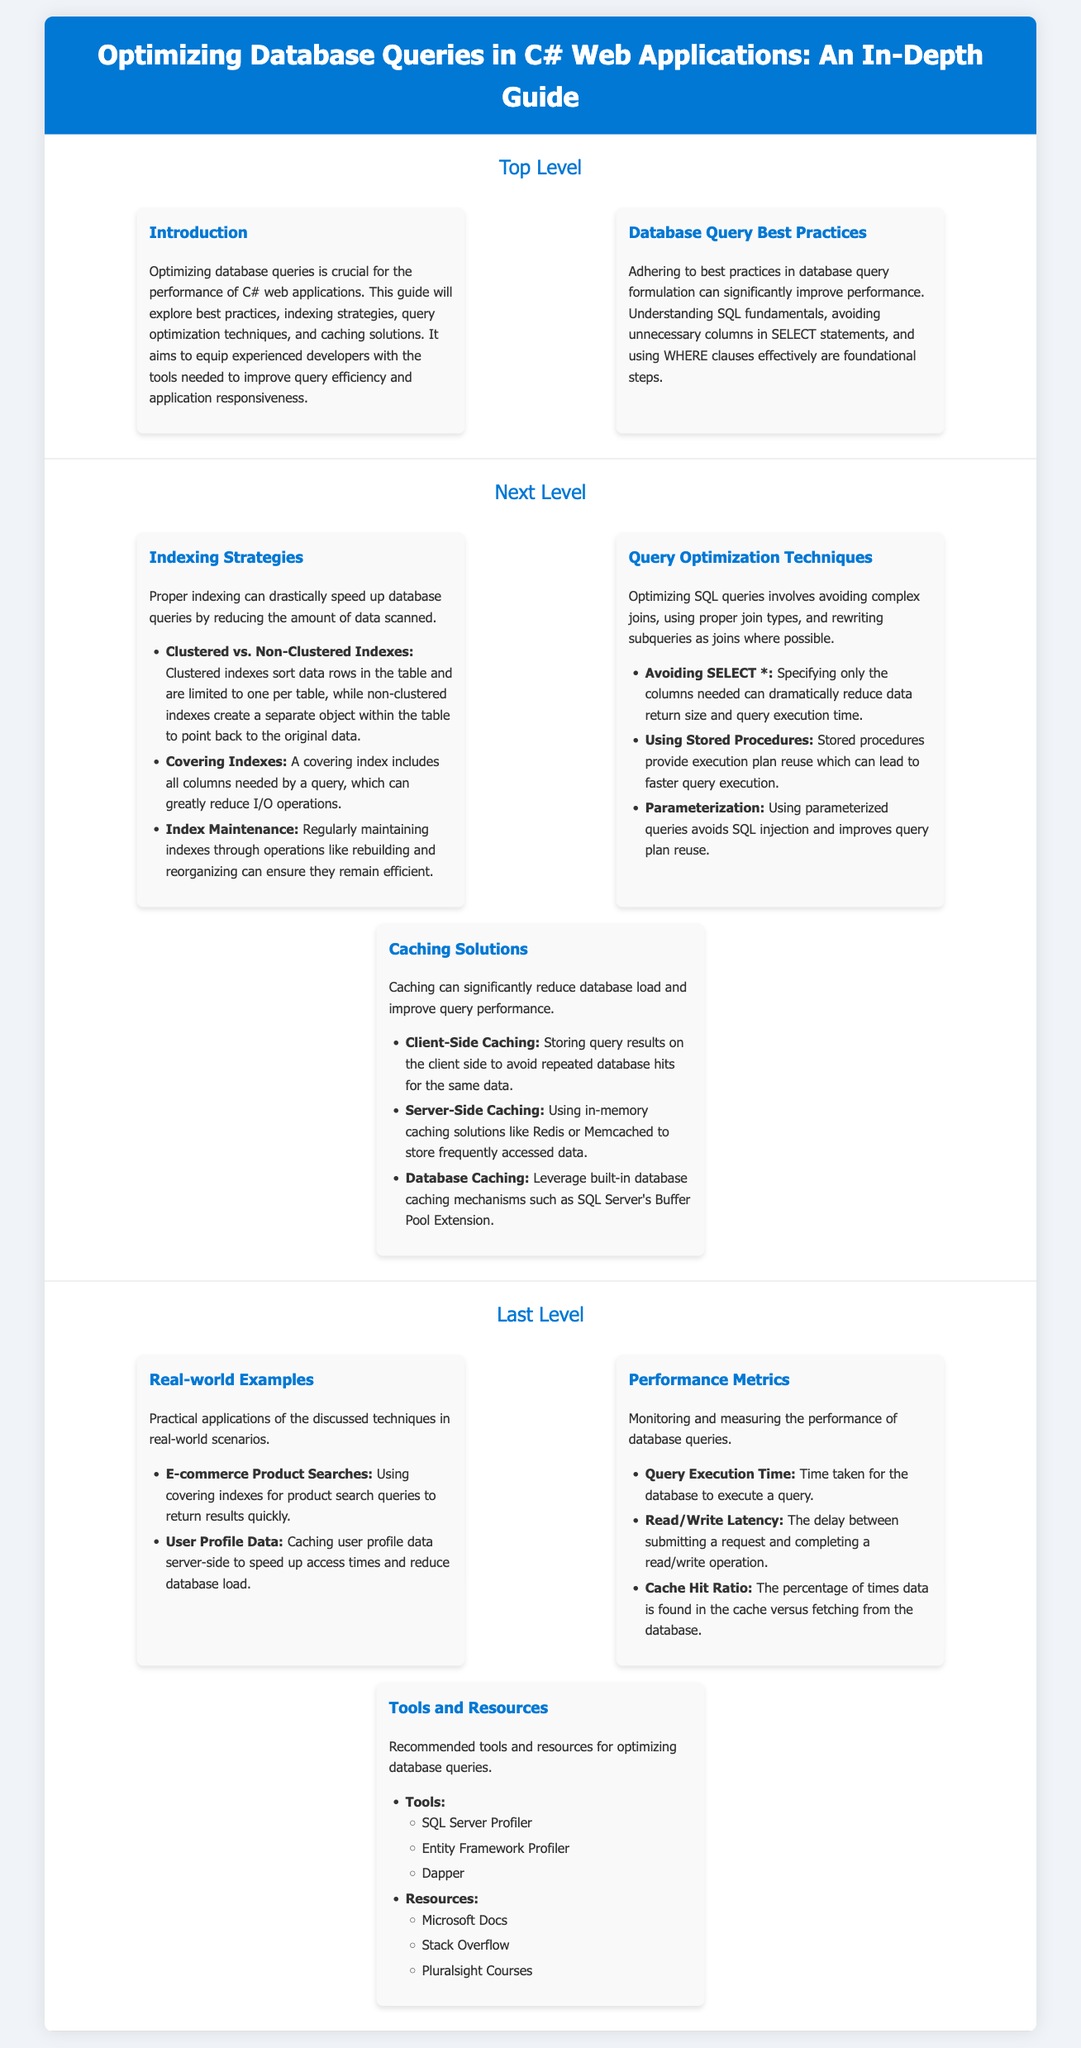What is the title of the document? The title of the document is found at the top of the infographic, indicating the main subject discussed.
Answer: Optimizing Database Queries in C# Web Applications: An In-Depth Guide What are the three categories under Database Query Best Practices? The categories are identified in the infographic to provide structured options for optimization strategies.
Answer: Indexing Strategies, Query Optimization Techniques, Caching Solutions What type of indexes does the document differentiate between? The differences in index types help clarify their roles and functions in database optimization.
Answer: Clustered vs. Non-Clustered Indexes What is a key benefit of using stored procedures according to the document? The explanation provides insight into the advantages that stored procedures offer for query execution.
Answer: Faster query execution Which caching solution is mentioned for storing frequently accessed data? The solution listed highlights options available for improving query performance through caching.
Answer: Redis or Memcached What does the Cache Hit Ratio measure? The measure is defined in the document to provide clarity on its importance in assessing caching effectiveness.
Answer: Percentage of times data is found in the cache How many examples are provided under Real-world Examples? The number of examples illustrates the practical application of the discussed optimization techniques in specific scenarios.
Answer: Two Which tool is mentioned for monitoring database performance? The specific tool noted supports developers in tracking and enhancing performance within their database interactions.
Answer: SQL Server Profiler 